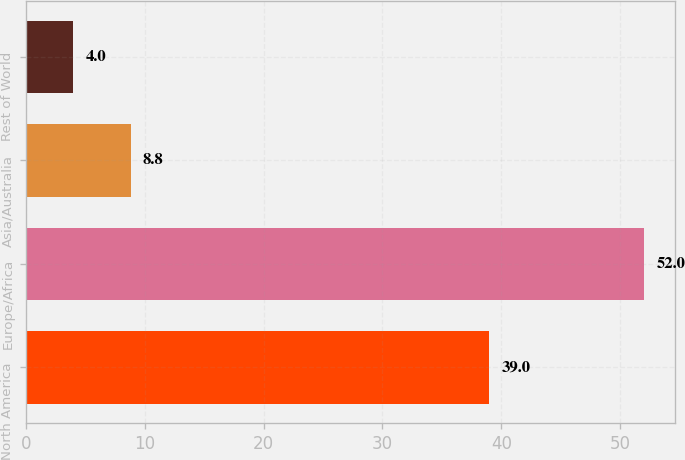Convert chart. <chart><loc_0><loc_0><loc_500><loc_500><bar_chart><fcel>North America<fcel>Europe/Africa<fcel>Asia/Australia<fcel>Rest of World<nl><fcel>39<fcel>52<fcel>8.8<fcel>4<nl></chart> 